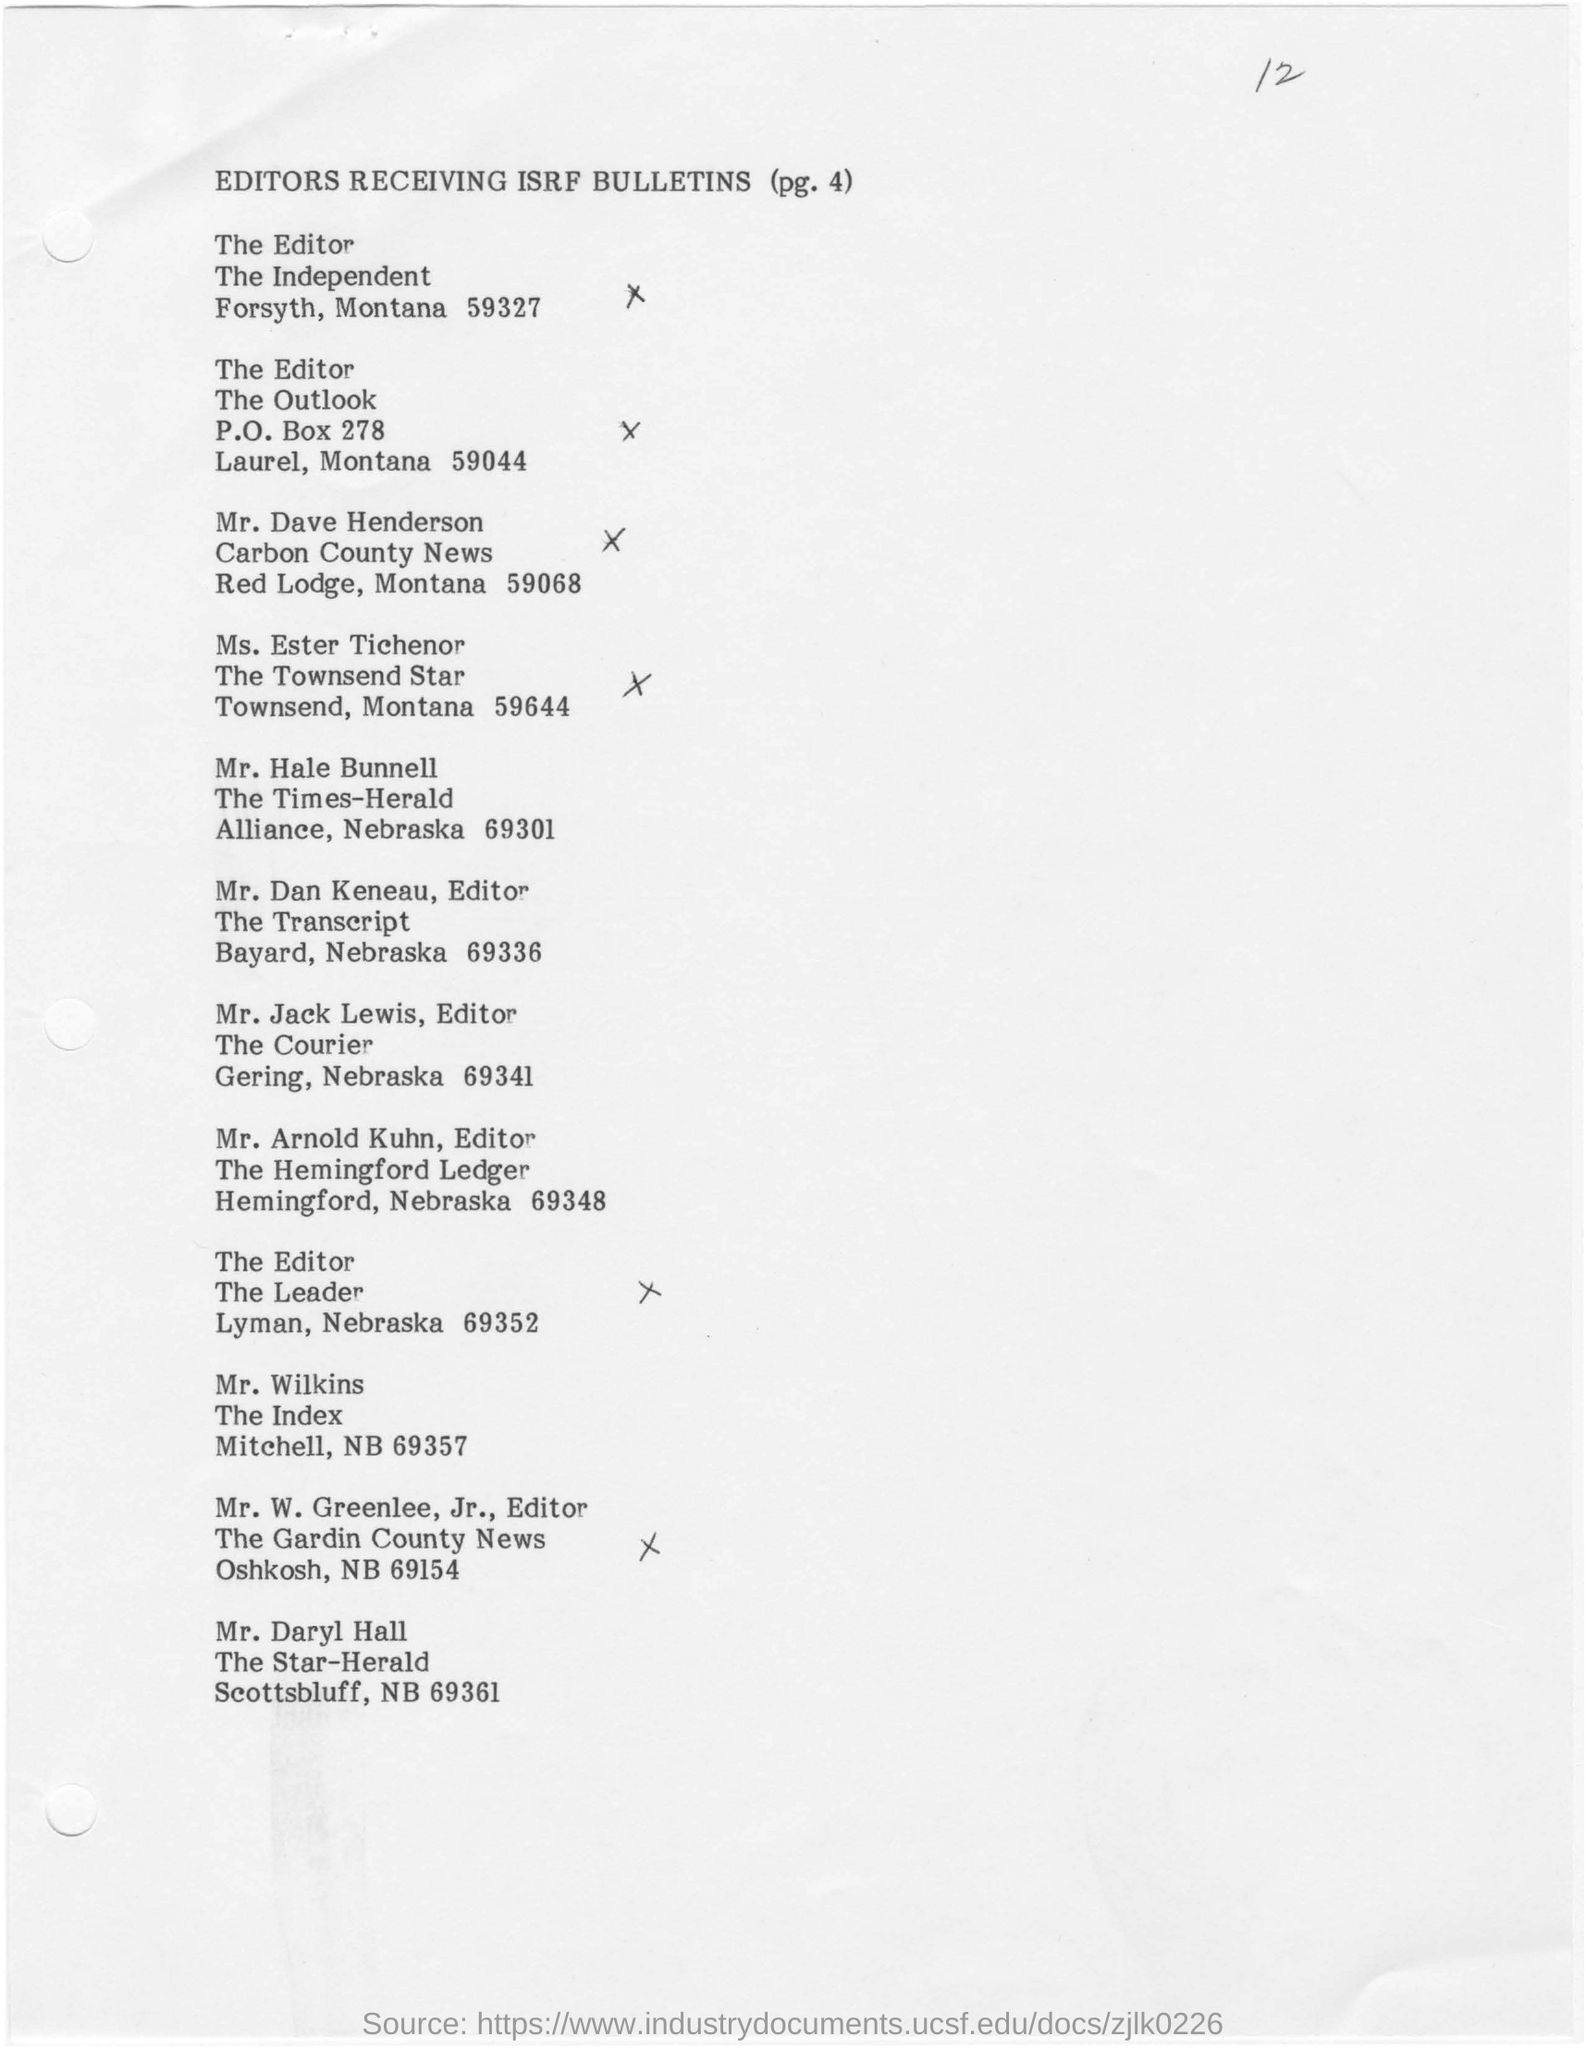Mention a couple of crucial points in this snapshot. This document bears the heading "EDITORS RECEIVING ISRF BULLETINS (PG. 4)." 